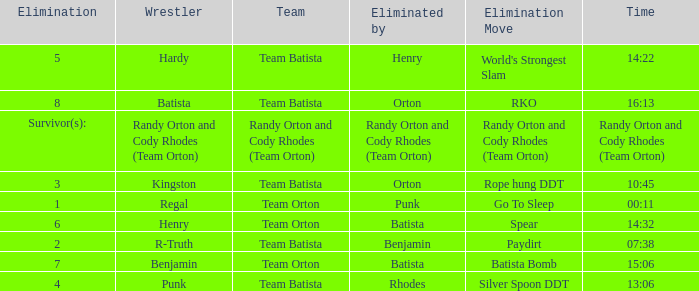What is the Elimination move listed against Regal? Go To Sleep. 